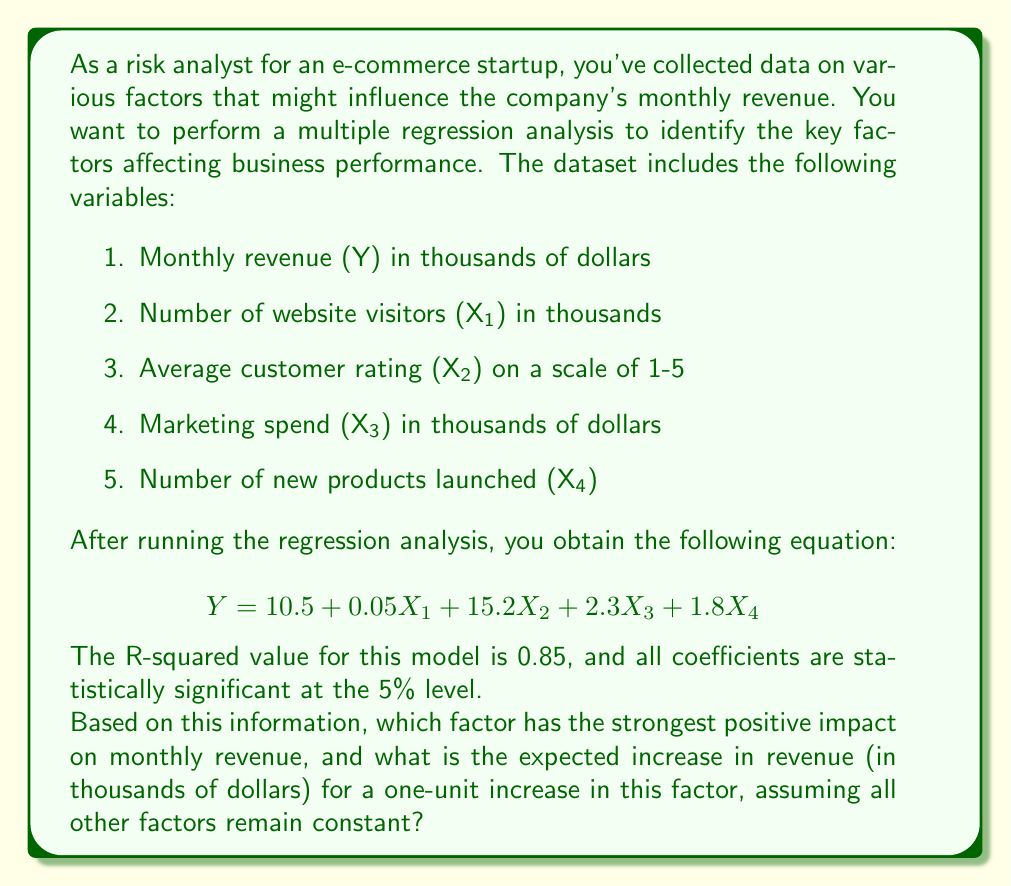Provide a solution to this math problem. To determine which factor has the strongest positive impact on monthly revenue, we need to compare the coefficients of each independent variable in the regression equation. However, we must be cautious about directly comparing coefficients because the variables are measured in different units. Instead, we should consider the practical implications of a one-unit change in each variable.

Let's examine each coefficient:

1. $X_1$ (Number of website visitors): 0.05
   - A one-unit increase (1,000 visitors) leads to a $50 increase in revenue.

2. $X_2$ (Average customer rating): 15.2
   - A one-unit increase in rating leads to a $15,200 increase in revenue.

3. $X_3$ (Marketing spend): 2.3
   - A one-unit increase ($1,000 in spending) leads to a $2,300 increase in revenue.

4. $X_4$ (Number of new products launched): 1.8
   - A one-unit increase (1 new product) leads to a $1,800 increase in revenue.

Comparing these effects, we can see that the average customer rating ($X_2$) has the strongest positive impact on monthly revenue. A one-unit increase in the average customer rating (e.g., from 3 to 4 on the 1-5 scale) is associated with a $15,200 increase in monthly revenue, assuming all other factors remain constant.

This makes sense from a business perspective, as higher customer ratings often lead to increased customer trust, repeat purchases, and positive word-of-mouth marketing, all of which can significantly boost revenue.
Answer: Average customer rating; $15,200 